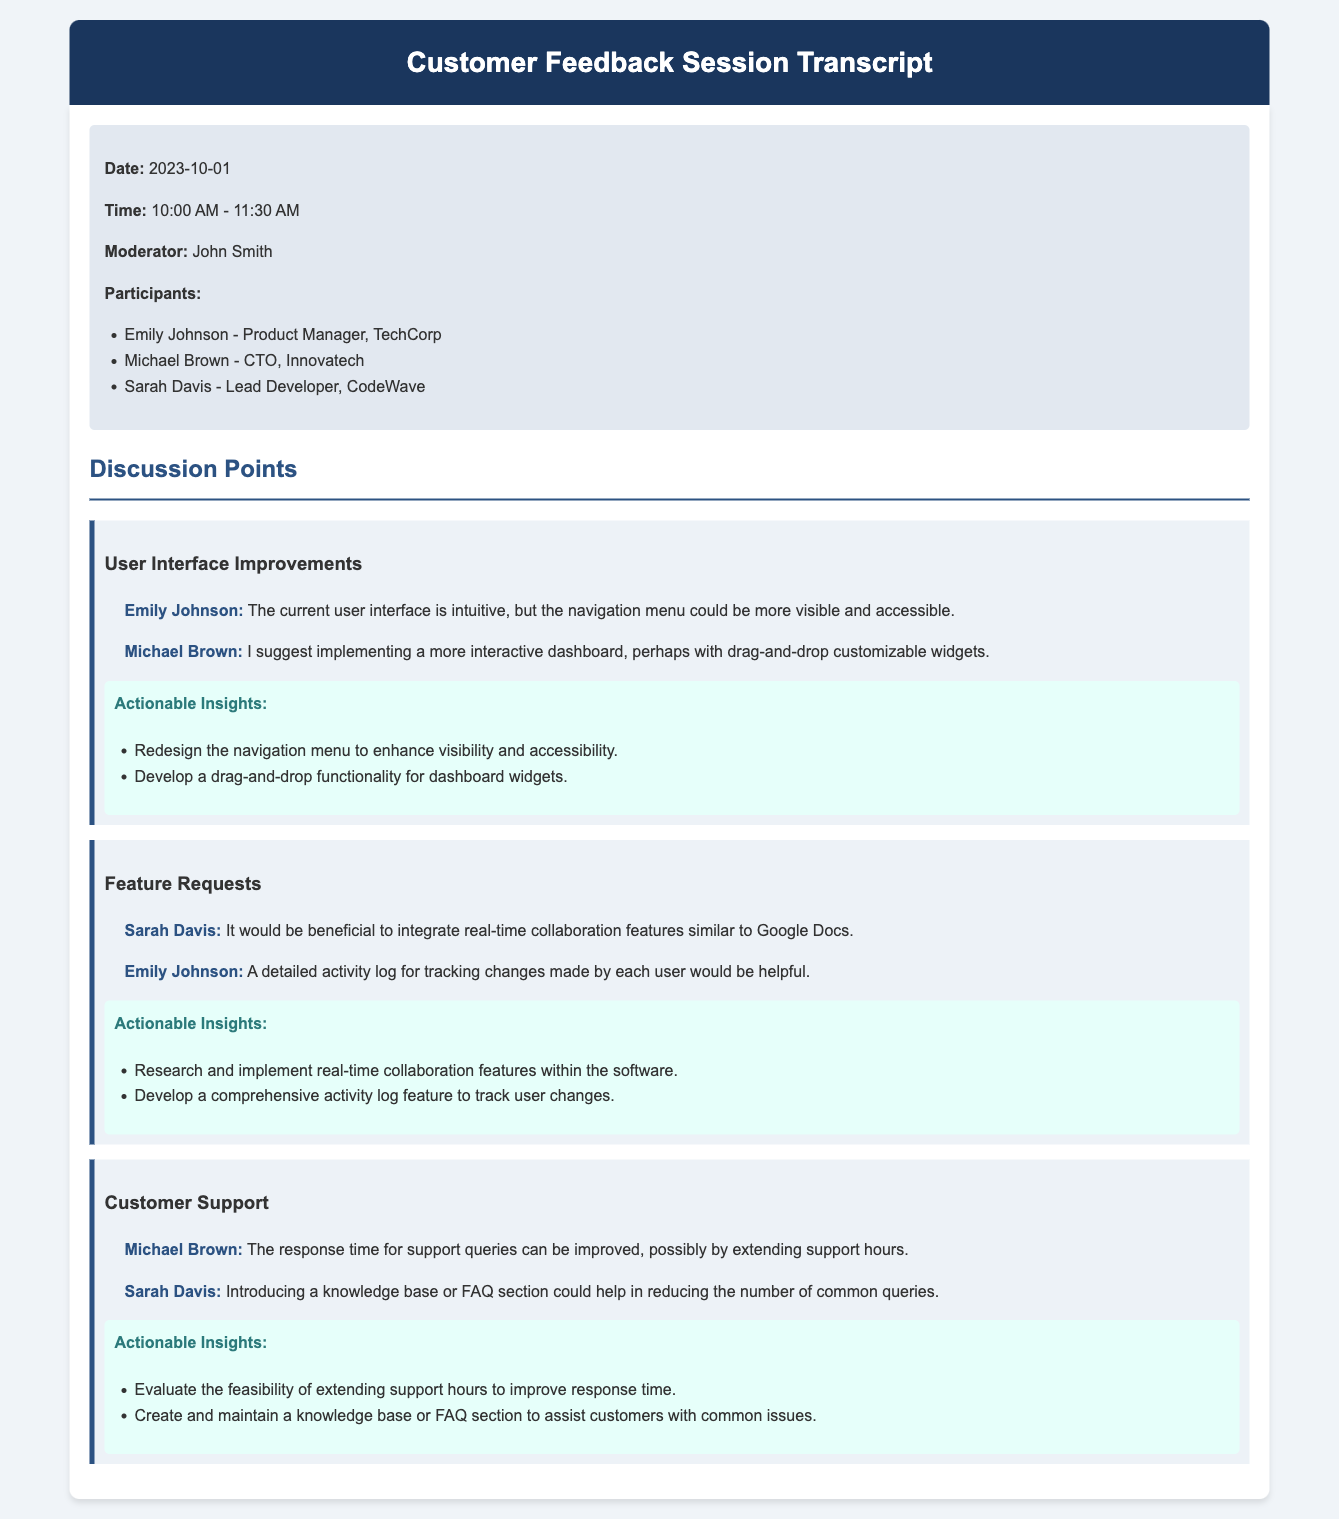What is the date of the customer feedback session? The date is specified in the session details at the beginning of the document.
Answer: 2023-10-01 Who moderated the session? The moderator's name is clearly indicated in the session details section.
Answer: John Smith What is one suggestion made for the user interface? The document lists feedback from participants under each discussion point; I can locate a suggestion there.
Answer: Redesign the navigation menu Which participant suggested integrating real-time collaboration features? The feedback section attributes certain suggestions to specific participants, including their names.
Answer: Sarah Davis What is one actionable insight regarding customer support? Actionable insights for each discussion point are included in the document.
Answer: Evaluate the feasibility of extending support hours How long did the session last? The time the session started and ended is provided, allowing calculation of its duration.
Answer: 1 hour 30 minutes What feature relates to tracking changes made by users? The feedback mentions specific features that address this concern, found in the feature requests section.
Answer: Detailed activity log Which company does Emily Johnson represent? The participant details provide information about each individual's affiliation.
Answer: TechCorp What color is the header background? The document describes styles for various elements, including the header's background color.
Answer: Dark Blue 